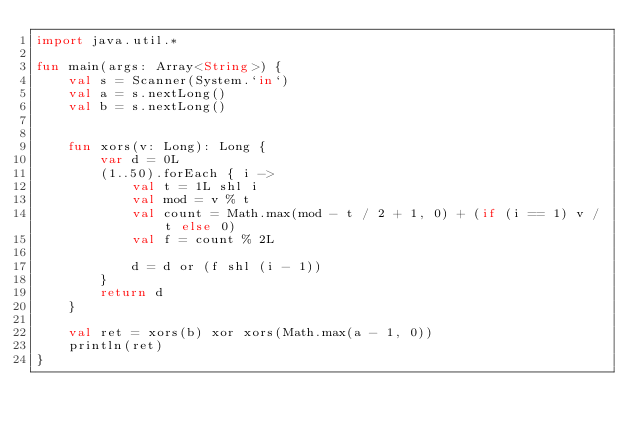<code> <loc_0><loc_0><loc_500><loc_500><_Kotlin_>import java.util.*

fun main(args: Array<String>) {
    val s = Scanner(System.`in`)
    val a = s.nextLong()
    val b = s.nextLong()


    fun xors(v: Long): Long {
        var d = 0L
        (1..50).forEach { i ->
            val t = 1L shl i
            val mod = v % t
            val count = Math.max(mod - t / 2 + 1, 0) + (if (i == 1) v / t else 0)
            val f = count % 2L

            d = d or (f shl (i - 1))
        }
        return d
    }

    val ret = xors(b) xor xors(Math.max(a - 1, 0))
    println(ret)
}</code> 